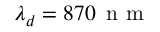Convert formula to latex. <formula><loc_0><loc_0><loc_500><loc_500>\lambda _ { d } = 8 7 0 \, n m</formula> 